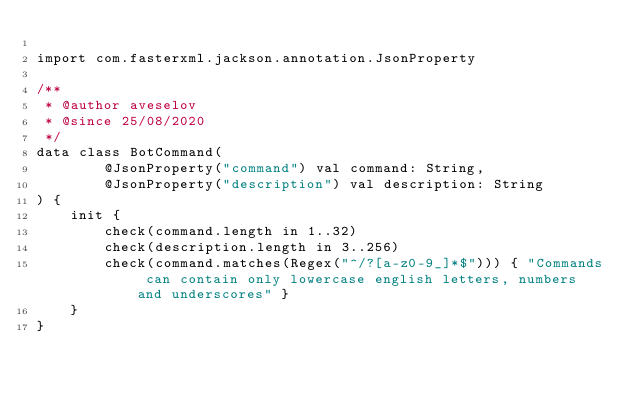<code> <loc_0><loc_0><loc_500><loc_500><_Kotlin_>
import com.fasterxml.jackson.annotation.JsonProperty

/**
 * @author aveselov
 * @since 25/08/2020
 */
data class BotCommand(
        @JsonProperty("command") val command: String,
        @JsonProperty("description") val description: String
) {
    init {
        check(command.length in 1..32)
        check(description.length in 3..256)
        check(command.matches(Regex("^/?[a-z0-9_]*$"))) { "Commands can contain only lowercase english letters, numbers and underscores" }
    }
}</code> 